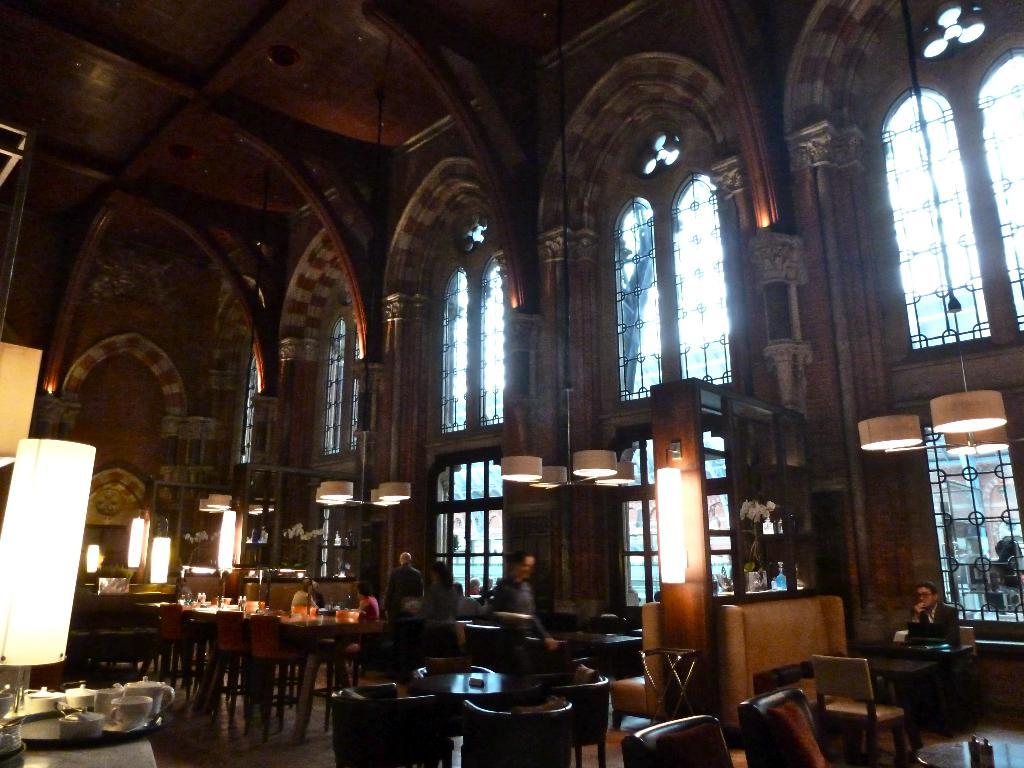What type of setting is shown in the image? The image depicts a restaurant setting. What are the people in the image doing? There are people seated on chairs and people standing in the image. What can be seen hanging from the ceiling in the image? There are lights in the image. What type of tableware is present in the image? There are cups in the image. What type of furniture is present in the image? There are tables and chairs in the image. What type of fog can be seen in the image? There is no fog present in the image. 